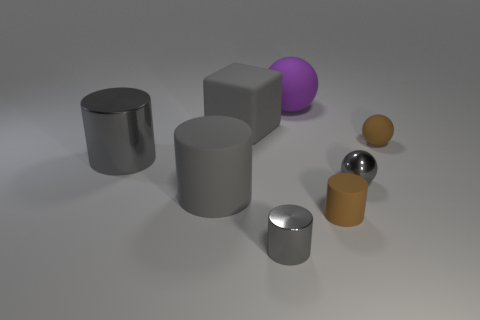Subtract all gray spheres. How many gray cylinders are left? 3 Add 1 large gray matte things. How many objects exist? 9 Subtract all balls. How many objects are left? 5 Subtract 0 yellow blocks. How many objects are left? 8 Subtract all big gray matte things. Subtract all metallic objects. How many objects are left? 3 Add 8 tiny metal balls. How many tiny metal balls are left? 9 Add 4 brown objects. How many brown objects exist? 6 